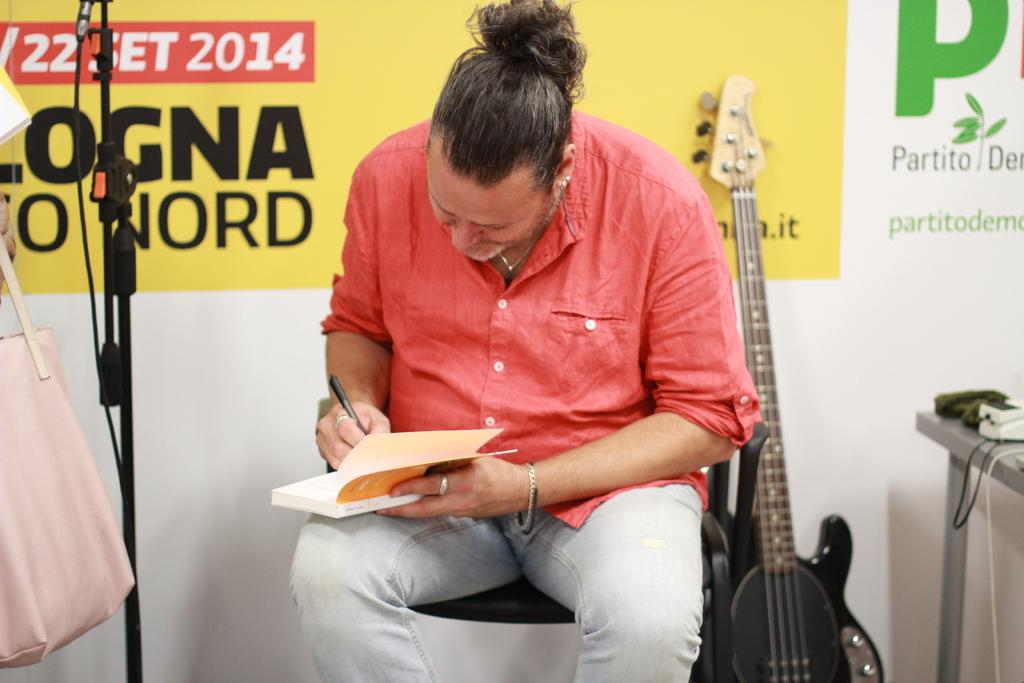<image>
Create a compact narrative representing the image presented. A man writes down in a book in front of a Logna sign. 